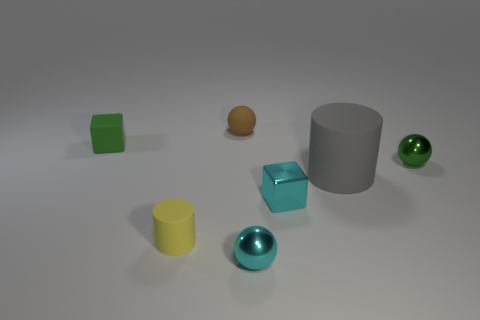Add 2 gray matte cylinders. How many objects exist? 9 Subtract all blocks. How many objects are left? 5 Subtract all gray rubber cylinders. Subtract all yellow objects. How many objects are left? 5 Add 5 tiny balls. How many tiny balls are left? 8 Add 5 balls. How many balls exist? 8 Subtract 0 gray balls. How many objects are left? 7 